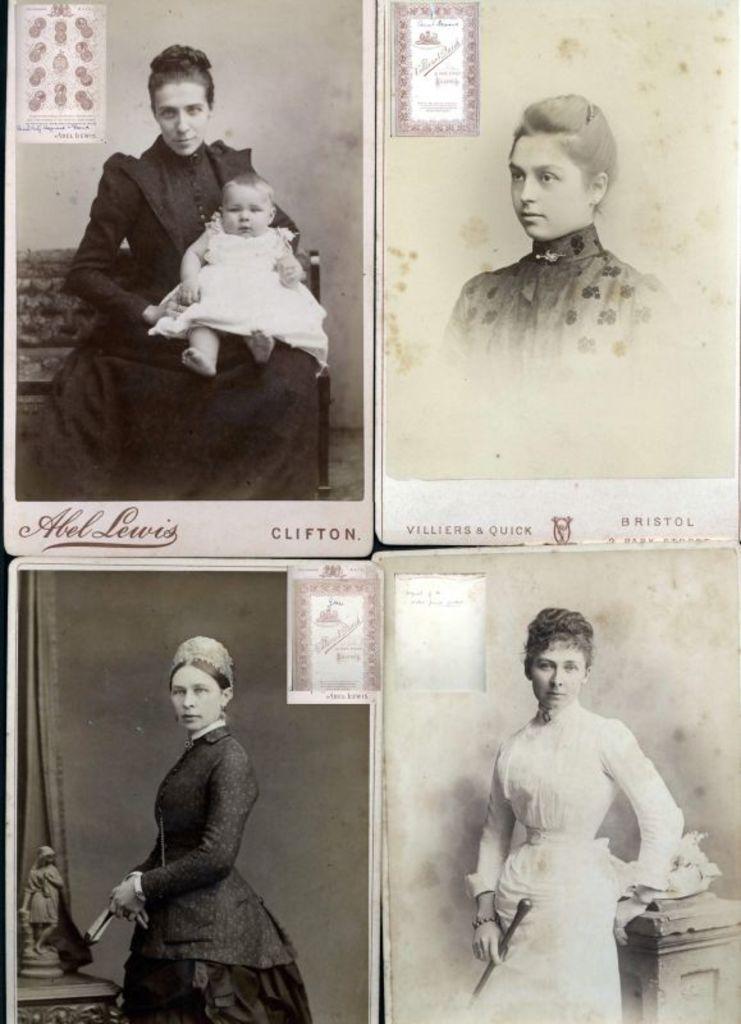Can you describe this image briefly? It is a black and white picture. It is a collage image of four different people. 